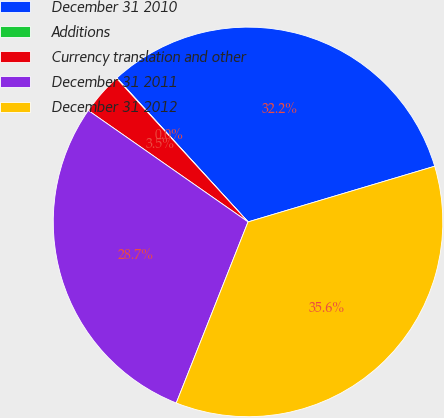Convert chart. <chart><loc_0><loc_0><loc_500><loc_500><pie_chart><fcel>December 31 2010<fcel>Additions<fcel>Currency translation and other<fcel>December 31 2011<fcel>December 31 2012<nl><fcel>32.15%<fcel>0.04%<fcel>3.5%<fcel>28.69%<fcel>35.62%<nl></chart> 